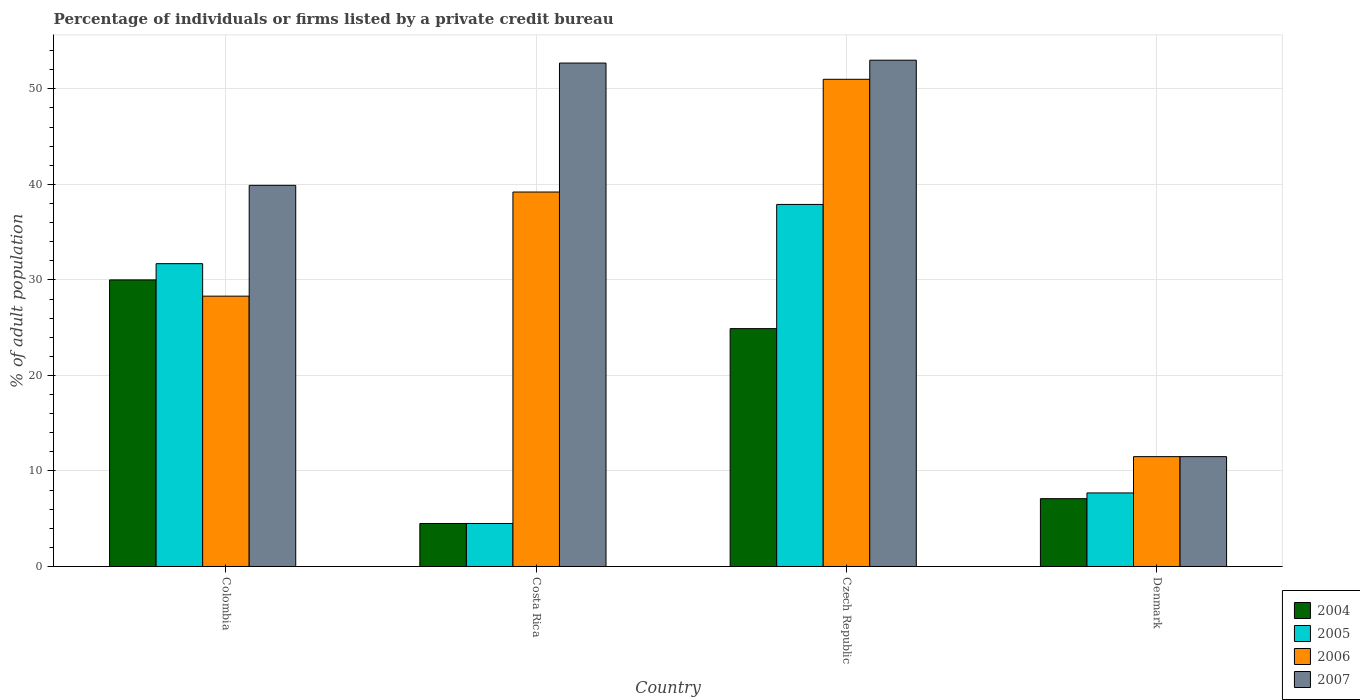How many groups of bars are there?
Ensure brevity in your answer.  4. Are the number of bars per tick equal to the number of legend labels?
Keep it short and to the point. Yes. Are the number of bars on each tick of the X-axis equal?
Offer a very short reply. Yes. What is the label of the 4th group of bars from the left?
Your response must be concise. Denmark. In how many cases, is the number of bars for a given country not equal to the number of legend labels?
Offer a terse response. 0. What is the percentage of population listed by a private credit bureau in 2007 in Czech Republic?
Provide a short and direct response. 53. Across all countries, what is the minimum percentage of population listed by a private credit bureau in 2005?
Your answer should be compact. 4.5. In which country was the percentage of population listed by a private credit bureau in 2007 maximum?
Offer a very short reply. Czech Republic. In which country was the percentage of population listed by a private credit bureau in 2005 minimum?
Offer a terse response. Costa Rica. What is the total percentage of population listed by a private credit bureau in 2004 in the graph?
Give a very brief answer. 66.5. What is the difference between the percentage of population listed by a private credit bureau in 2006 in Denmark and the percentage of population listed by a private credit bureau in 2005 in Colombia?
Keep it short and to the point. -20.2. What is the average percentage of population listed by a private credit bureau in 2007 per country?
Your answer should be very brief. 39.27. In how many countries, is the percentage of population listed by a private credit bureau in 2007 greater than 30 %?
Your response must be concise. 3. What is the ratio of the percentage of population listed by a private credit bureau in 2005 in Colombia to that in Costa Rica?
Your response must be concise. 7.04. Is the difference between the percentage of population listed by a private credit bureau in 2007 in Czech Republic and Denmark greater than the difference between the percentage of population listed by a private credit bureau in 2004 in Czech Republic and Denmark?
Your answer should be compact. Yes. What is the difference between the highest and the second highest percentage of population listed by a private credit bureau in 2007?
Provide a short and direct response. -0.3. What is the difference between the highest and the lowest percentage of population listed by a private credit bureau in 2004?
Give a very brief answer. 25.5. Is the sum of the percentage of population listed by a private credit bureau in 2004 in Costa Rica and Czech Republic greater than the maximum percentage of population listed by a private credit bureau in 2005 across all countries?
Your response must be concise. No. What does the 3rd bar from the left in Colombia represents?
Your answer should be very brief. 2006. What does the 2nd bar from the right in Denmark represents?
Make the answer very short. 2006. Are all the bars in the graph horizontal?
Provide a short and direct response. No. Are the values on the major ticks of Y-axis written in scientific E-notation?
Offer a very short reply. No. Does the graph contain any zero values?
Your answer should be compact. No. Does the graph contain grids?
Provide a short and direct response. Yes. What is the title of the graph?
Ensure brevity in your answer.  Percentage of individuals or firms listed by a private credit bureau. What is the label or title of the Y-axis?
Offer a very short reply. % of adult population. What is the % of adult population of 2004 in Colombia?
Keep it short and to the point. 30. What is the % of adult population of 2005 in Colombia?
Provide a short and direct response. 31.7. What is the % of adult population of 2006 in Colombia?
Your answer should be compact. 28.3. What is the % of adult population in 2007 in Colombia?
Provide a succinct answer. 39.9. What is the % of adult population in 2006 in Costa Rica?
Give a very brief answer. 39.2. What is the % of adult population of 2007 in Costa Rica?
Keep it short and to the point. 52.7. What is the % of adult population in 2004 in Czech Republic?
Keep it short and to the point. 24.9. What is the % of adult population of 2005 in Czech Republic?
Your answer should be compact. 37.9. What is the % of adult population in 2006 in Czech Republic?
Keep it short and to the point. 51. What is the % of adult population of 2005 in Denmark?
Your answer should be very brief. 7.7. What is the % of adult population in 2006 in Denmark?
Offer a terse response. 11.5. Across all countries, what is the maximum % of adult population in 2005?
Provide a succinct answer. 37.9. Across all countries, what is the maximum % of adult population in 2006?
Offer a terse response. 51. Across all countries, what is the minimum % of adult population of 2004?
Ensure brevity in your answer.  4.5. Across all countries, what is the minimum % of adult population of 2005?
Keep it short and to the point. 4.5. Across all countries, what is the minimum % of adult population in 2006?
Keep it short and to the point. 11.5. Across all countries, what is the minimum % of adult population of 2007?
Your answer should be very brief. 11.5. What is the total % of adult population in 2004 in the graph?
Keep it short and to the point. 66.5. What is the total % of adult population in 2005 in the graph?
Your response must be concise. 81.8. What is the total % of adult population in 2006 in the graph?
Your answer should be compact. 130. What is the total % of adult population of 2007 in the graph?
Your answer should be compact. 157.1. What is the difference between the % of adult population in 2005 in Colombia and that in Costa Rica?
Provide a succinct answer. 27.2. What is the difference between the % of adult population of 2007 in Colombia and that in Costa Rica?
Offer a terse response. -12.8. What is the difference between the % of adult population of 2006 in Colombia and that in Czech Republic?
Your response must be concise. -22.7. What is the difference between the % of adult population in 2004 in Colombia and that in Denmark?
Provide a succinct answer. 22.9. What is the difference between the % of adult population in 2007 in Colombia and that in Denmark?
Offer a very short reply. 28.4. What is the difference between the % of adult population in 2004 in Costa Rica and that in Czech Republic?
Your response must be concise. -20.4. What is the difference between the % of adult population of 2005 in Costa Rica and that in Czech Republic?
Your response must be concise. -33.4. What is the difference between the % of adult population in 2006 in Costa Rica and that in Czech Republic?
Give a very brief answer. -11.8. What is the difference between the % of adult population of 2007 in Costa Rica and that in Czech Republic?
Your response must be concise. -0.3. What is the difference between the % of adult population in 2005 in Costa Rica and that in Denmark?
Your answer should be compact. -3.2. What is the difference between the % of adult population in 2006 in Costa Rica and that in Denmark?
Make the answer very short. 27.7. What is the difference between the % of adult population in 2007 in Costa Rica and that in Denmark?
Give a very brief answer. 41.2. What is the difference between the % of adult population in 2004 in Czech Republic and that in Denmark?
Ensure brevity in your answer.  17.8. What is the difference between the % of adult population of 2005 in Czech Republic and that in Denmark?
Offer a very short reply. 30.2. What is the difference between the % of adult population of 2006 in Czech Republic and that in Denmark?
Make the answer very short. 39.5. What is the difference between the % of adult population in 2007 in Czech Republic and that in Denmark?
Your answer should be very brief. 41.5. What is the difference between the % of adult population of 2004 in Colombia and the % of adult population of 2006 in Costa Rica?
Make the answer very short. -9.2. What is the difference between the % of adult population in 2004 in Colombia and the % of adult population in 2007 in Costa Rica?
Offer a terse response. -22.7. What is the difference between the % of adult population in 2005 in Colombia and the % of adult population in 2007 in Costa Rica?
Make the answer very short. -21. What is the difference between the % of adult population of 2006 in Colombia and the % of adult population of 2007 in Costa Rica?
Provide a short and direct response. -24.4. What is the difference between the % of adult population of 2004 in Colombia and the % of adult population of 2005 in Czech Republic?
Provide a succinct answer. -7.9. What is the difference between the % of adult population in 2004 in Colombia and the % of adult population in 2006 in Czech Republic?
Make the answer very short. -21. What is the difference between the % of adult population of 2005 in Colombia and the % of adult population of 2006 in Czech Republic?
Your answer should be compact. -19.3. What is the difference between the % of adult population in 2005 in Colombia and the % of adult population in 2007 in Czech Republic?
Provide a short and direct response. -21.3. What is the difference between the % of adult population in 2006 in Colombia and the % of adult population in 2007 in Czech Republic?
Provide a succinct answer. -24.7. What is the difference between the % of adult population in 2004 in Colombia and the % of adult population in 2005 in Denmark?
Your answer should be compact. 22.3. What is the difference between the % of adult population in 2004 in Colombia and the % of adult population in 2006 in Denmark?
Give a very brief answer. 18.5. What is the difference between the % of adult population in 2004 in Colombia and the % of adult population in 2007 in Denmark?
Your response must be concise. 18.5. What is the difference between the % of adult population of 2005 in Colombia and the % of adult population of 2006 in Denmark?
Provide a succinct answer. 20.2. What is the difference between the % of adult population in 2005 in Colombia and the % of adult population in 2007 in Denmark?
Make the answer very short. 20.2. What is the difference between the % of adult population of 2006 in Colombia and the % of adult population of 2007 in Denmark?
Ensure brevity in your answer.  16.8. What is the difference between the % of adult population in 2004 in Costa Rica and the % of adult population in 2005 in Czech Republic?
Make the answer very short. -33.4. What is the difference between the % of adult population of 2004 in Costa Rica and the % of adult population of 2006 in Czech Republic?
Offer a very short reply. -46.5. What is the difference between the % of adult population in 2004 in Costa Rica and the % of adult population in 2007 in Czech Republic?
Offer a terse response. -48.5. What is the difference between the % of adult population in 2005 in Costa Rica and the % of adult population in 2006 in Czech Republic?
Make the answer very short. -46.5. What is the difference between the % of adult population in 2005 in Costa Rica and the % of adult population in 2007 in Czech Republic?
Give a very brief answer. -48.5. What is the difference between the % of adult population of 2004 in Costa Rica and the % of adult population of 2005 in Denmark?
Provide a succinct answer. -3.2. What is the difference between the % of adult population of 2004 in Costa Rica and the % of adult population of 2006 in Denmark?
Keep it short and to the point. -7. What is the difference between the % of adult population in 2004 in Costa Rica and the % of adult population in 2007 in Denmark?
Your answer should be very brief. -7. What is the difference between the % of adult population in 2006 in Costa Rica and the % of adult population in 2007 in Denmark?
Make the answer very short. 27.7. What is the difference between the % of adult population of 2004 in Czech Republic and the % of adult population of 2006 in Denmark?
Give a very brief answer. 13.4. What is the difference between the % of adult population of 2004 in Czech Republic and the % of adult population of 2007 in Denmark?
Give a very brief answer. 13.4. What is the difference between the % of adult population in 2005 in Czech Republic and the % of adult population in 2006 in Denmark?
Provide a short and direct response. 26.4. What is the difference between the % of adult population of 2005 in Czech Republic and the % of adult population of 2007 in Denmark?
Your answer should be very brief. 26.4. What is the difference between the % of adult population of 2006 in Czech Republic and the % of adult population of 2007 in Denmark?
Offer a terse response. 39.5. What is the average % of adult population of 2004 per country?
Keep it short and to the point. 16.62. What is the average % of adult population of 2005 per country?
Make the answer very short. 20.45. What is the average % of adult population of 2006 per country?
Provide a short and direct response. 32.5. What is the average % of adult population in 2007 per country?
Ensure brevity in your answer.  39.27. What is the difference between the % of adult population in 2004 and % of adult population in 2005 in Colombia?
Your response must be concise. -1.7. What is the difference between the % of adult population in 2004 and % of adult population in 2006 in Colombia?
Ensure brevity in your answer.  1.7. What is the difference between the % of adult population of 2005 and % of adult population of 2006 in Colombia?
Make the answer very short. 3.4. What is the difference between the % of adult population in 2005 and % of adult population in 2007 in Colombia?
Give a very brief answer. -8.2. What is the difference between the % of adult population of 2004 and % of adult population of 2005 in Costa Rica?
Make the answer very short. 0. What is the difference between the % of adult population in 2004 and % of adult population in 2006 in Costa Rica?
Offer a terse response. -34.7. What is the difference between the % of adult population of 2004 and % of adult population of 2007 in Costa Rica?
Provide a succinct answer. -48.2. What is the difference between the % of adult population in 2005 and % of adult population in 2006 in Costa Rica?
Your answer should be compact. -34.7. What is the difference between the % of adult population of 2005 and % of adult population of 2007 in Costa Rica?
Keep it short and to the point. -48.2. What is the difference between the % of adult population of 2004 and % of adult population of 2006 in Czech Republic?
Give a very brief answer. -26.1. What is the difference between the % of adult population in 2004 and % of adult population in 2007 in Czech Republic?
Your answer should be very brief. -28.1. What is the difference between the % of adult population of 2005 and % of adult population of 2007 in Czech Republic?
Give a very brief answer. -15.1. What is the difference between the % of adult population of 2004 and % of adult population of 2006 in Denmark?
Your answer should be compact. -4.4. What is the difference between the % of adult population of 2004 and % of adult population of 2007 in Denmark?
Keep it short and to the point. -4.4. What is the difference between the % of adult population in 2005 and % of adult population in 2006 in Denmark?
Give a very brief answer. -3.8. What is the difference between the % of adult population of 2005 and % of adult population of 2007 in Denmark?
Offer a very short reply. -3.8. What is the ratio of the % of adult population of 2004 in Colombia to that in Costa Rica?
Provide a short and direct response. 6.67. What is the ratio of the % of adult population of 2005 in Colombia to that in Costa Rica?
Your answer should be compact. 7.04. What is the ratio of the % of adult population in 2006 in Colombia to that in Costa Rica?
Provide a short and direct response. 0.72. What is the ratio of the % of adult population in 2007 in Colombia to that in Costa Rica?
Ensure brevity in your answer.  0.76. What is the ratio of the % of adult population of 2004 in Colombia to that in Czech Republic?
Keep it short and to the point. 1.2. What is the ratio of the % of adult population of 2005 in Colombia to that in Czech Republic?
Your answer should be very brief. 0.84. What is the ratio of the % of adult population of 2006 in Colombia to that in Czech Republic?
Your answer should be compact. 0.55. What is the ratio of the % of adult population in 2007 in Colombia to that in Czech Republic?
Give a very brief answer. 0.75. What is the ratio of the % of adult population of 2004 in Colombia to that in Denmark?
Offer a terse response. 4.23. What is the ratio of the % of adult population in 2005 in Colombia to that in Denmark?
Provide a short and direct response. 4.12. What is the ratio of the % of adult population of 2006 in Colombia to that in Denmark?
Keep it short and to the point. 2.46. What is the ratio of the % of adult population in 2007 in Colombia to that in Denmark?
Ensure brevity in your answer.  3.47. What is the ratio of the % of adult population in 2004 in Costa Rica to that in Czech Republic?
Keep it short and to the point. 0.18. What is the ratio of the % of adult population of 2005 in Costa Rica to that in Czech Republic?
Make the answer very short. 0.12. What is the ratio of the % of adult population of 2006 in Costa Rica to that in Czech Republic?
Offer a very short reply. 0.77. What is the ratio of the % of adult population of 2004 in Costa Rica to that in Denmark?
Keep it short and to the point. 0.63. What is the ratio of the % of adult population in 2005 in Costa Rica to that in Denmark?
Ensure brevity in your answer.  0.58. What is the ratio of the % of adult population in 2006 in Costa Rica to that in Denmark?
Give a very brief answer. 3.41. What is the ratio of the % of adult population in 2007 in Costa Rica to that in Denmark?
Offer a terse response. 4.58. What is the ratio of the % of adult population of 2004 in Czech Republic to that in Denmark?
Your response must be concise. 3.51. What is the ratio of the % of adult population in 2005 in Czech Republic to that in Denmark?
Keep it short and to the point. 4.92. What is the ratio of the % of adult population of 2006 in Czech Republic to that in Denmark?
Provide a short and direct response. 4.43. What is the ratio of the % of adult population of 2007 in Czech Republic to that in Denmark?
Offer a very short reply. 4.61. What is the difference between the highest and the second highest % of adult population of 2007?
Provide a short and direct response. 0.3. What is the difference between the highest and the lowest % of adult population in 2005?
Your answer should be very brief. 33.4. What is the difference between the highest and the lowest % of adult population of 2006?
Offer a very short reply. 39.5. What is the difference between the highest and the lowest % of adult population of 2007?
Offer a very short reply. 41.5. 